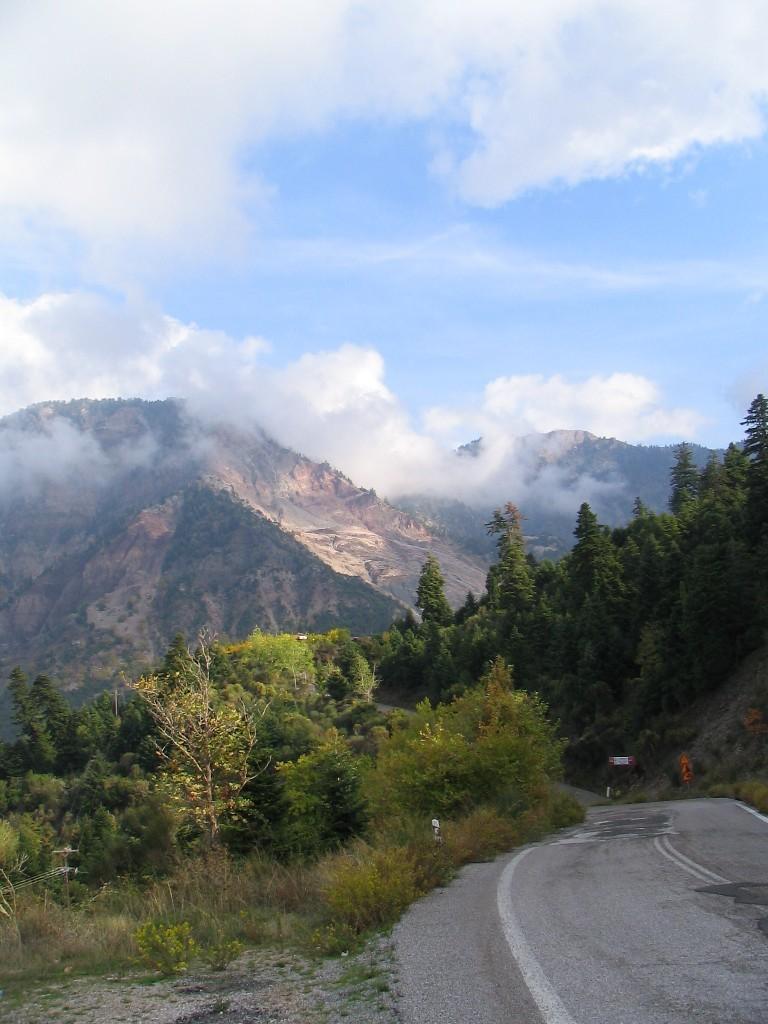In one or two sentences, can you explain what this image depicts? There is a road on the right. There are trees and mountains at the back. There are clouds in the sky. 